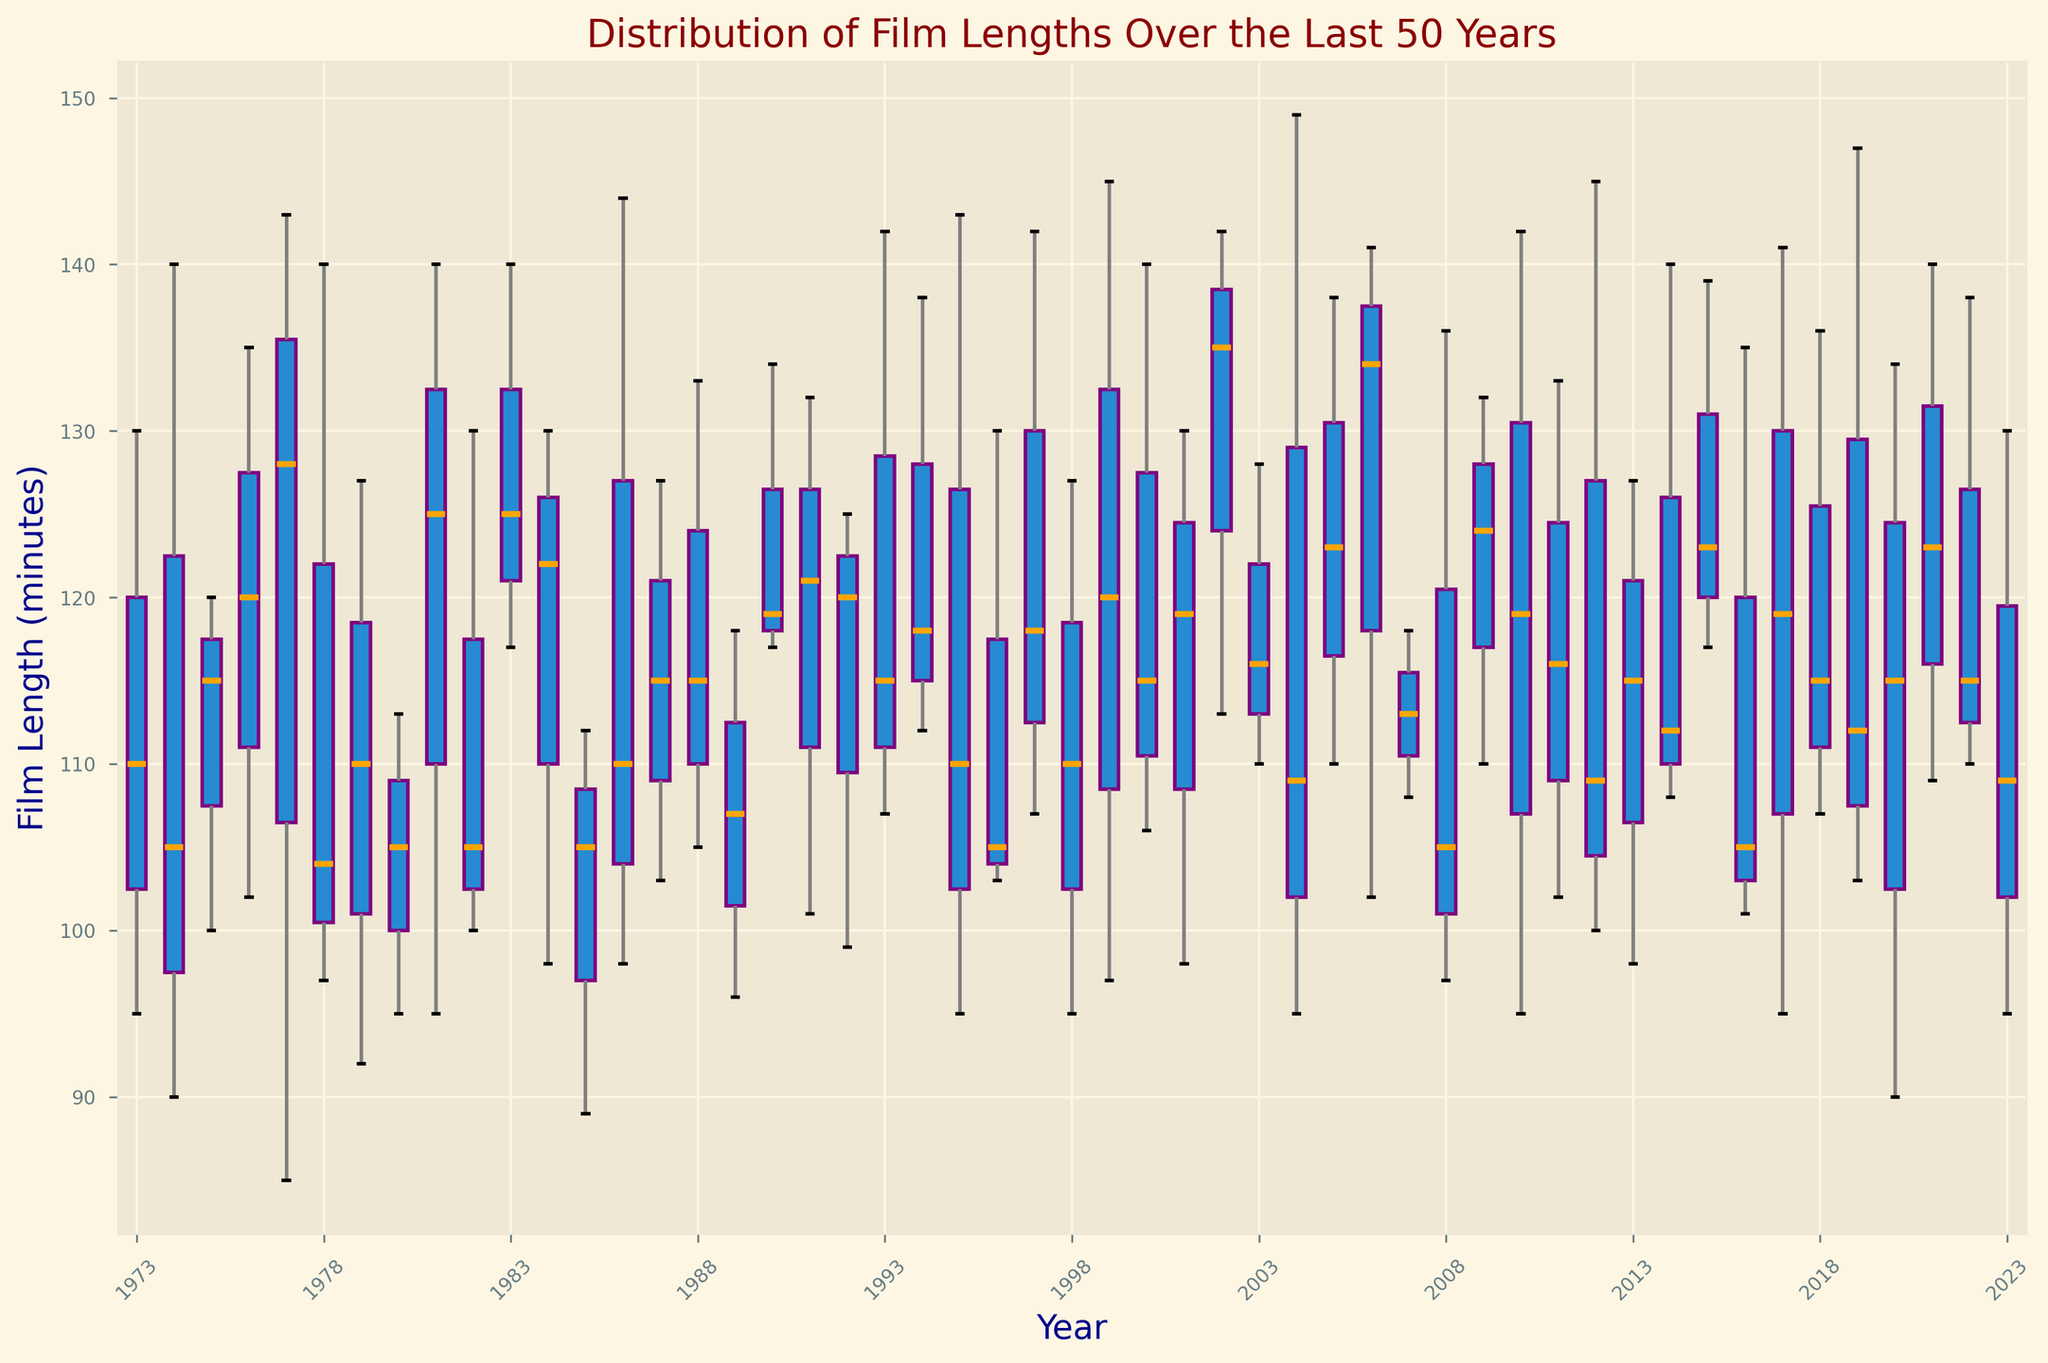What is the median film length in 1990? By locating the box associated with the year 1990 and finding the line inside the box, which represents the median, we can see that the median film length in 1990 is slightly above 115 minutes.
Answer: About 117 minutes Which year has the highest median film length? You need to scan the horizontal lines inside the boxes of the box plots for each year and identify which line is the highest.
Answer: One of the highest median years is around 2004 or 2005 Is the range of film lengths wider in 1986 or 1999? Look at the length of the whiskers and any outliers (dots) for the years 1986 and 1999. The wider the spread, the greater the range of film lengths.
Answer: 1999 In which year do we see the smallest interquartile range (IQR)? The interquartile range is represented by the height of the box. Look for the shortest box height across all years to identify the smallest IQR.
Answer: 1982 Are there any years where the minimum film length is much lower than the other years? Observe the lower whiskers across the box plots to see if any year's minimum length is significantly lower than the rest.
Answer: 2020, 1974 Which year has the largest number of outliers? Count the number of outliers (small dots) for each year to find out which year has the most.
Answer: 1986 or 2004 Between the years 2000 and 2020, during which period did film lengths show the most variability? Evaluate the height of the boxes and the spread of the whiskers between the years 2000 and 2020. The most variability is indicated by the largest spread.
Answer: Around 2010-2012 Do films get generally longer or shorter over the years based on the median length? Follow the progression of the median lines (inside the boxes) over the years to determine if they trend upward or downward.
Answer: Slightly longer In 1995, how much longer is the upper quartile than the lower quartile? Find the length representing the upper quartile (top edge of the box) and the lower quartile (bottom edge of the box) and subtract the lower from the upper.
Answer: About 18 minutes Which year has a higher median film length, 1984 or 2017? Compare the position of the median line within the boxes for the years 1984 and 2017.
Answer: 2017 